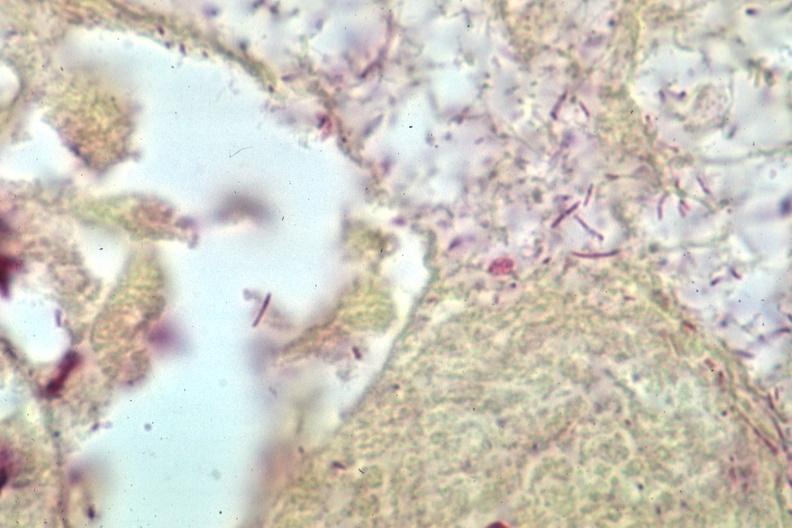does hemorrhage in newborn show grams stain gram negative bacteria?
Answer the question using a single word or phrase. No 